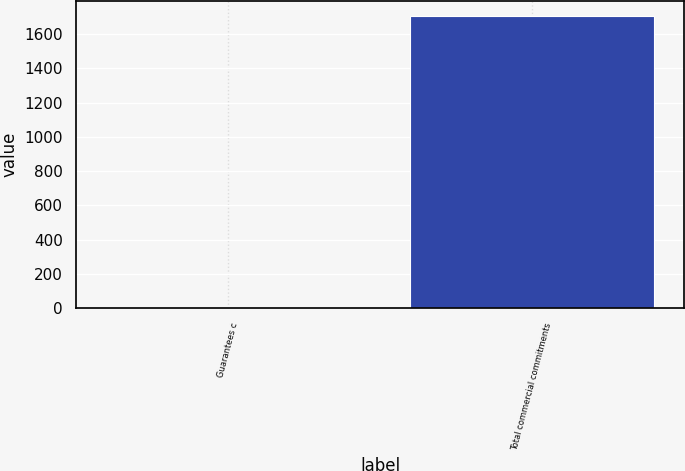<chart> <loc_0><loc_0><loc_500><loc_500><bar_chart><fcel>Guarantees c<fcel>Total commercial commitments<nl><fcel>8<fcel>1708<nl></chart> 